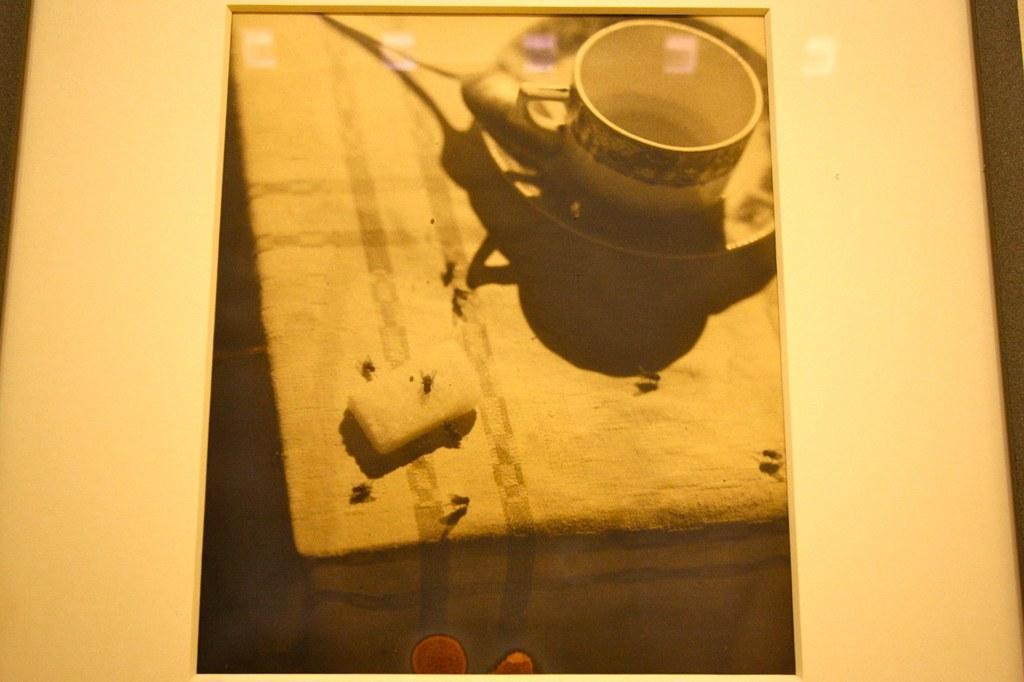In one or two sentences, can you explain what this image depicts? In this image I can see a photo frame which has white borders. There is a photo of a cup, saucer and there are flies. 